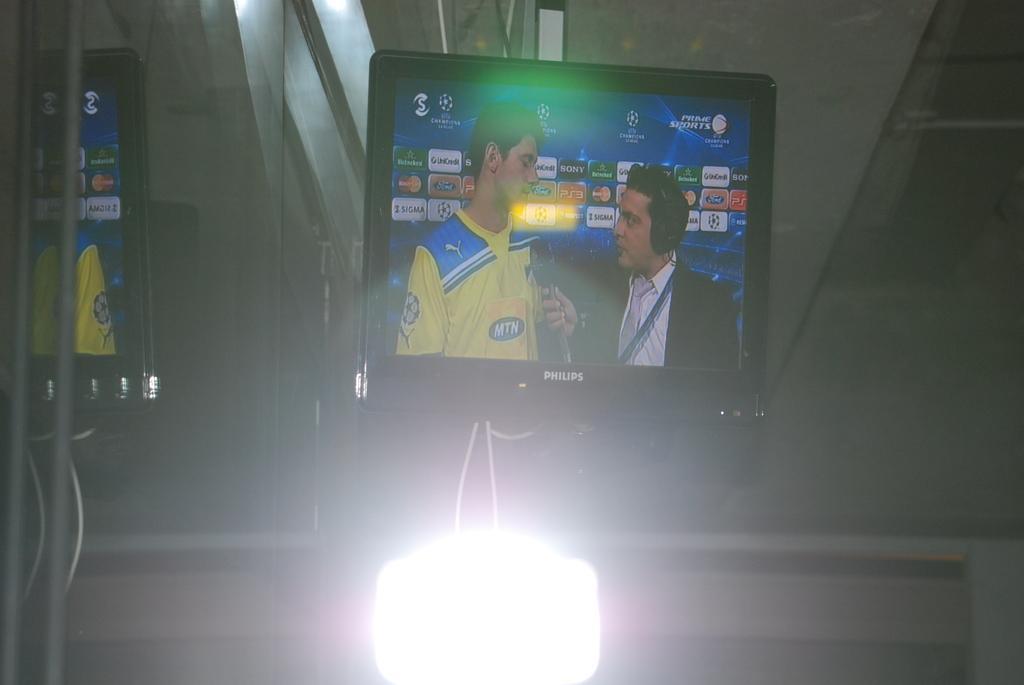<image>
Give a short and clear explanation of the subsequent image. A man is being interviewed on a Philips TV. 